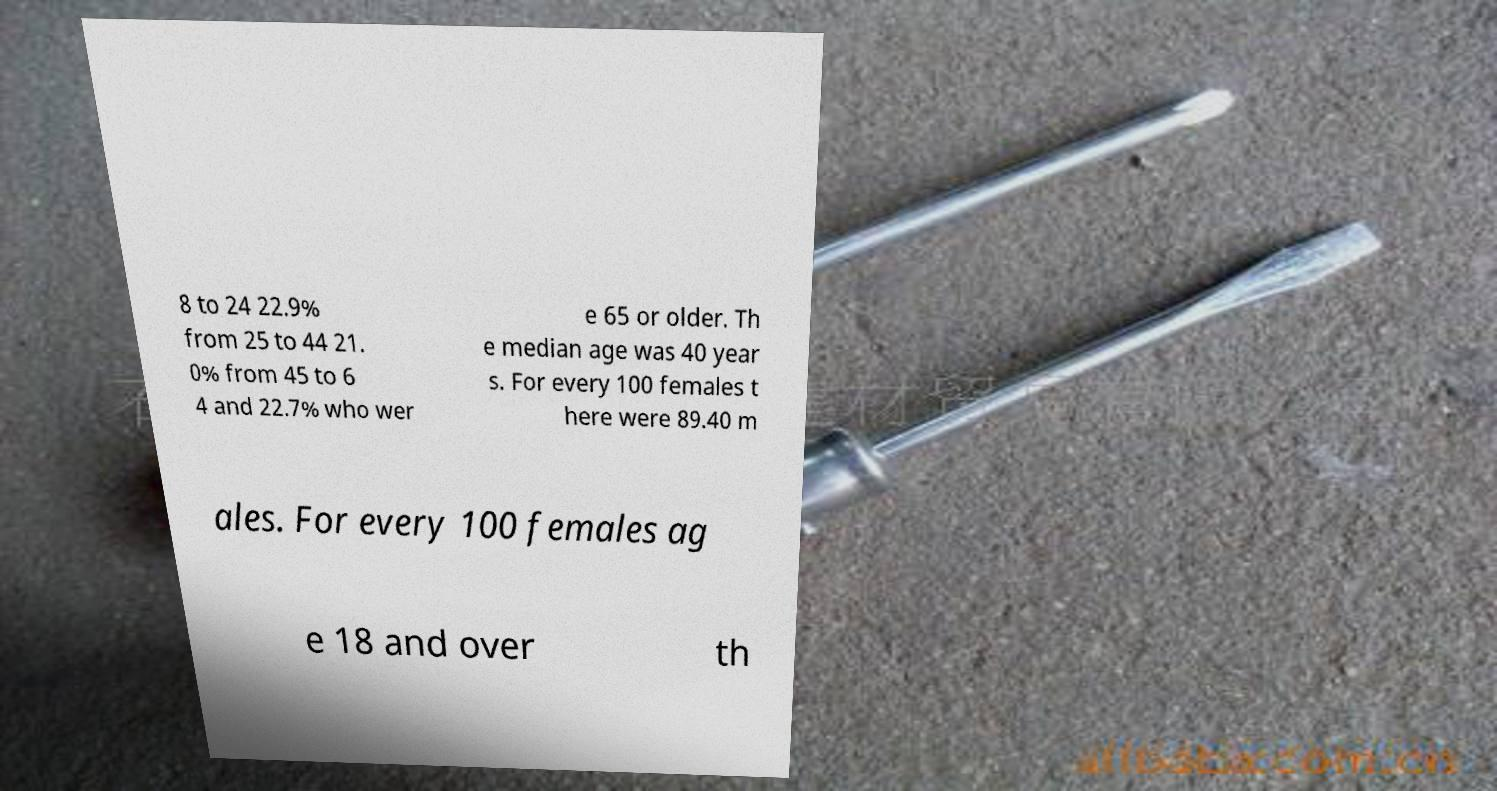Can you read and provide the text displayed in the image?This photo seems to have some interesting text. Can you extract and type it out for me? 8 to 24 22.9% from 25 to 44 21. 0% from 45 to 6 4 and 22.7% who wer e 65 or older. Th e median age was 40 year s. For every 100 females t here were 89.40 m ales. For every 100 females ag e 18 and over th 